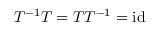<formula> <loc_0><loc_0><loc_500><loc_500>T ^ { - 1 } T = T T ^ { - 1 } = i d</formula> 